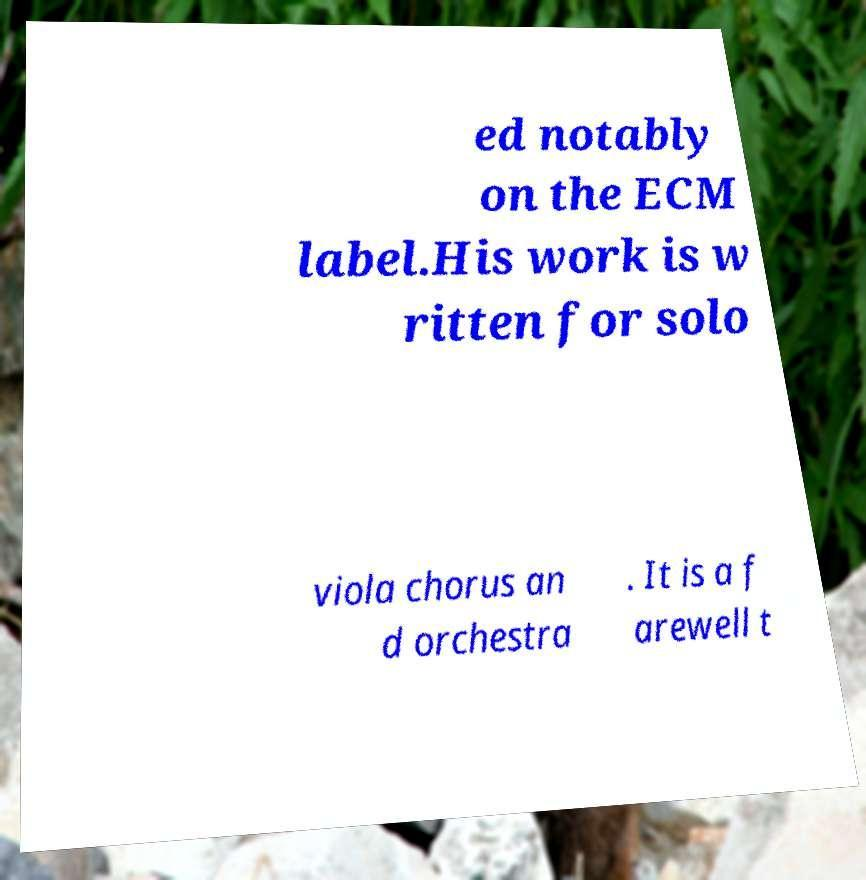For documentation purposes, I need the text within this image transcribed. Could you provide that? ed notably on the ECM label.His work is w ritten for solo viola chorus an d orchestra . It is a f arewell t 